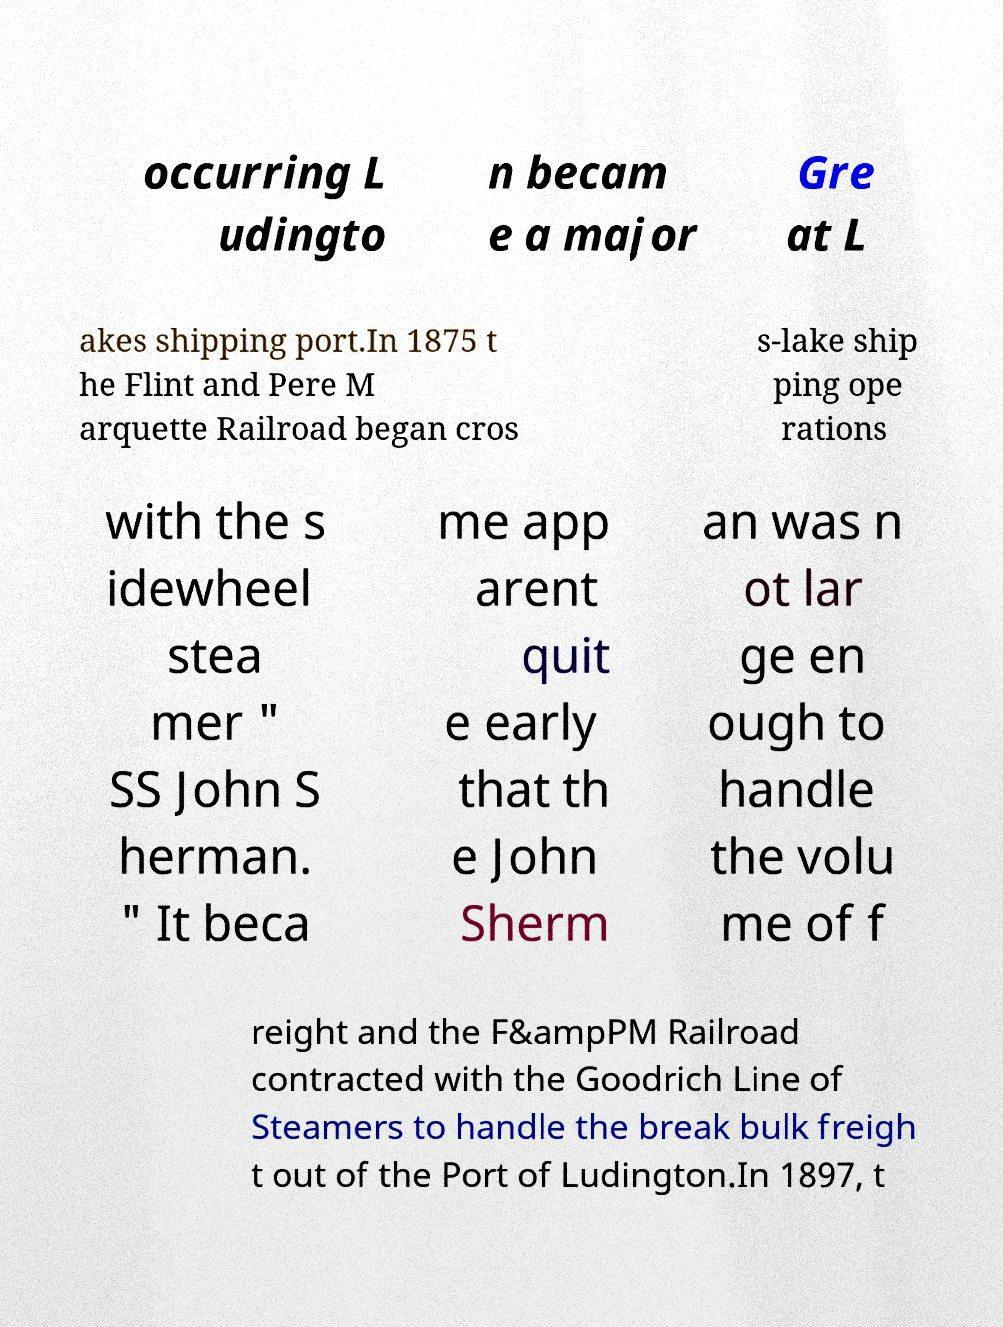There's text embedded in this image that I need extracted. Can you transcribe it verbatim? occurring L udingto n becam e a major Gre at L akes shipping port.In 1875 t he Flint and Pere M arquette Railroad began cros s-lake ship ping ope rations with the s idewheel stea mer " SS John S herman. " It beca me app arent quit e early that th e John Sherm an was n ot lar ge en ough to handle the volu me of f reight and the F&ampPM Railroad contracted with the Goodrich Line of Steamers to handle the break bulk freigh t out of the Port of Ludington.In 1897, t 